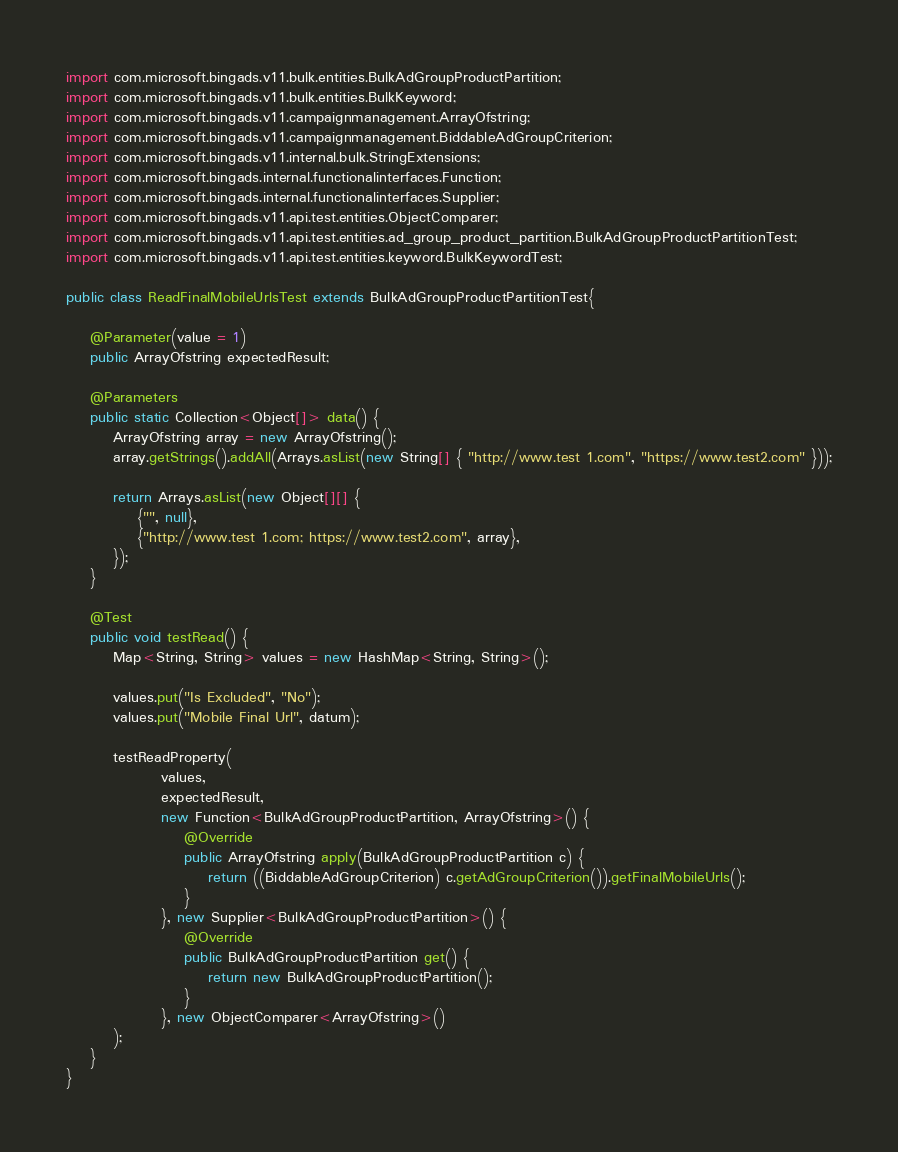<code> <loc_0><loc_0><loc_500><loc_500><_Java_>
import com.microsoft.bingads.v11.bulk.entities.BulkAdGroupProductPartition;
import com.microsoft.bingads.v11.bulk.entities.BulkKeyword;
import com.microsoft.bingads.v11.campaignmanagement.ArrayOfstring;
import com.microsoft.bingads.v11.campaignmanagement.BiddableAdGroupCriterion;
import com.microsoft.bingads.v11.internal.bulk.StringExtensions;
import com.microsoft.bingads.internal.functionalinterfaces.Function;
import com.microsoft.bingads.internal.functionalinterfaces.Supplier;
import com.microsoft.bingads.v11.api.test.entities.ObjectComparer;
import com.microsoft.bingads.v11.api.test.entities.ad_group_product_partition.BulkAdGroupProductPartitionTest;
import com.microsoft.bingads.v11.api.test.entities.keyword.BulkKeywordTest;

public class ReadFinalMobileUrlsTest extends BulkAdGroupProductPartitionTest{

	@Parameter(value = 1)
	public ArrayOfstring expectedResult;
	
	@Parameters
	public static Collection<Object[]> data() {
		ArrayOfstring array = new ArrayOfstring();
		array.getStrings().addAll(Arrays.asList(new String[] { "http://www.test 1.com", "https://www.test2.com" }));
		
		return Arrays.asList(new Object[][] {
			{"", null},
			{"http://www.test 1.com; https://www.test2.com", array},
		});
	}
	
	@Test
    public void testRead() {
        Map<String, String> values = new HashMap<String, String>();

        values.put("Is Excluded", "No");
        values.put("Mobile Final Url", datum);

        testReadProperty(
                values,
                expectedResult,
                new Function<BulkAdGroupProductPartition, ArrayOfstring>() {
                    @Override
                    public ArrayOfstring apply(BulkAdGroupProductPartition c) {
                        return ((BiddableAdGroupCriterion) c.getAdGroupCriterion()).getFinalMobileUrls();
                    }
                }, new Supplier<BulkAdGroupProductPartition>() {
                    @Override
                    public BulkAdGroupProductPartition get() {
                        return new BulkAdGroupProductPartition();
                    }
                }, new ObjectComparer<ArrayOfstring>()
        );
    }
}
</code> 